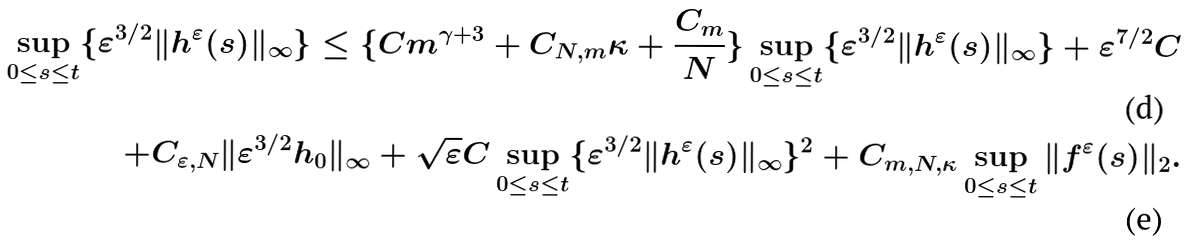Convert formula to latex. <formula><loc_0><loc_0><loc_500><loc_500>\sup _ { 0 \leq s \leq t } \{ \varepsilon ^ { 3 / 2 } \| h ^ { \varepsilon } ( s ) \| _ { \infty } \} \leq \{ C m ^ { \gamma + 3 } + C _ { N , m } \kappa + \frac { C _ { m } } { N } \} \sup _ { 0 \leq s \leq t } \{ \varepsilon ^ { 3 / 2 } \| h ^ { \varepsilon } ( s ) \| _ { \infty } \} + \varepsilon ^ { 7 / 2 } C \\ + C _ { \varepsilon , N } \| \varepsilon ^ { 3 / 2 } h _ { 0 } \| _ { \infty } + \sqrt { \varepsilon } C \sup _ { 0 \leq s \leq t } \{ \varepsilon ^ { 3 / 2 } \| h ^ { \varepsilon } ( s ) \| _ { \infty } \} ^ { 2 } + C _ { m , N , \kappa } \sup _ { 0 \leq s \leq t } \| f ^ { \varepsilon } ( s ) \| _ { 2 } .</formula> 